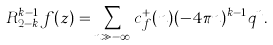Convert formula to latex. <formula><loc_0><loc_0><loc_500><loc_500>R _ { 2 - k } ^ { k - 1 } f ( z ) = \sum _ { n \gg - \infty } c _ { f } ^ { + } ( n ) ( - 4 \pi n ) ^ { k - 1 } q ^ { n } .</formula> 